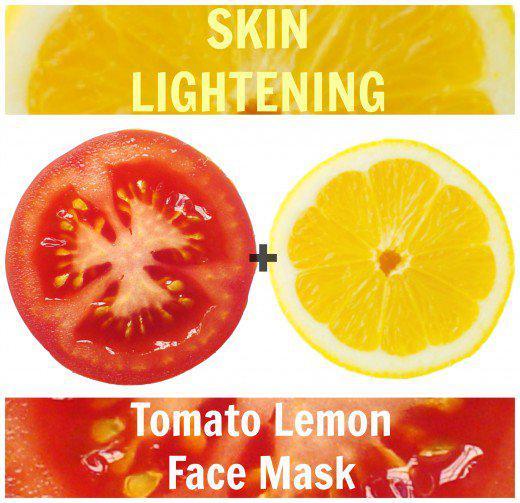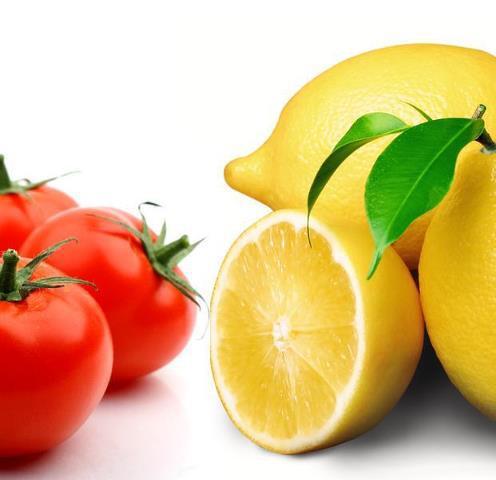The first image is the image on the left, the second image is the image on the right. Evaluate the accuracy of this statement regarding the images: "In the left image, there are the same number of lemons and tomatoes.". Is it true? Answer yes or no. Yes. 